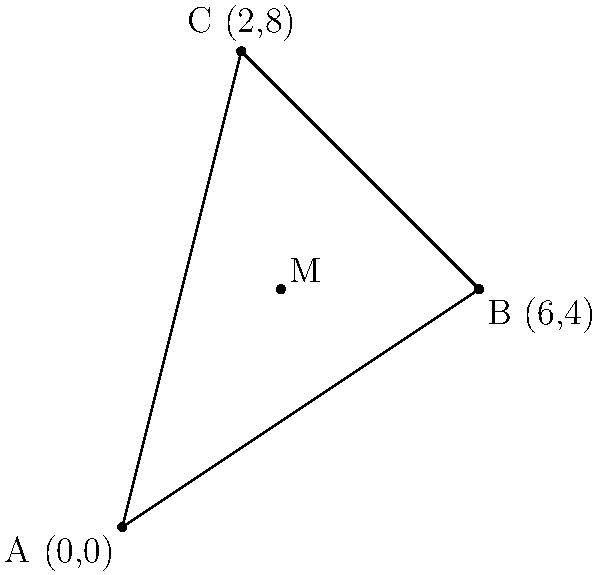In a recent investigation of a drone strike, three affected civilian locations were identified at coordinates A(0,0), B(6,4), and C(2,8). To determine the central point of impact, you need to find the coordinates of point M, which represents the centroid (geometric center) of the triangle formed by these locations. Calculate the coordinates of point M. To find the centroid (point M) of the triangle formed by points A, B, and C, we need to follow these steps:

1. The centroid of a triangle is located at the arithmetic mean of the coordinates of the three vertices.

2. For the x-coordinate of M:
   $x_M = \frac{x_A + x_B + x_C}{3} = \frac{0 + 6 + 2}{3} = \frac{8}{3} \approx 2.67$

3. For the y-coordinate of M:
   $y_M = \frac{y_A + y_B + y_C}{3} = \frac{0 + 4 + 8}{3} = 4$

4. Therefore, the coordinates of the centroid M are $(\frac{8}{3}, 4)$ or approximately (2.67, 4).

This point represents the geometric center of the area affected by the drone strike, based on the three identified locations.
Answer: $M(\frac{8}{3}, 4)$ or (2.67, 4) 